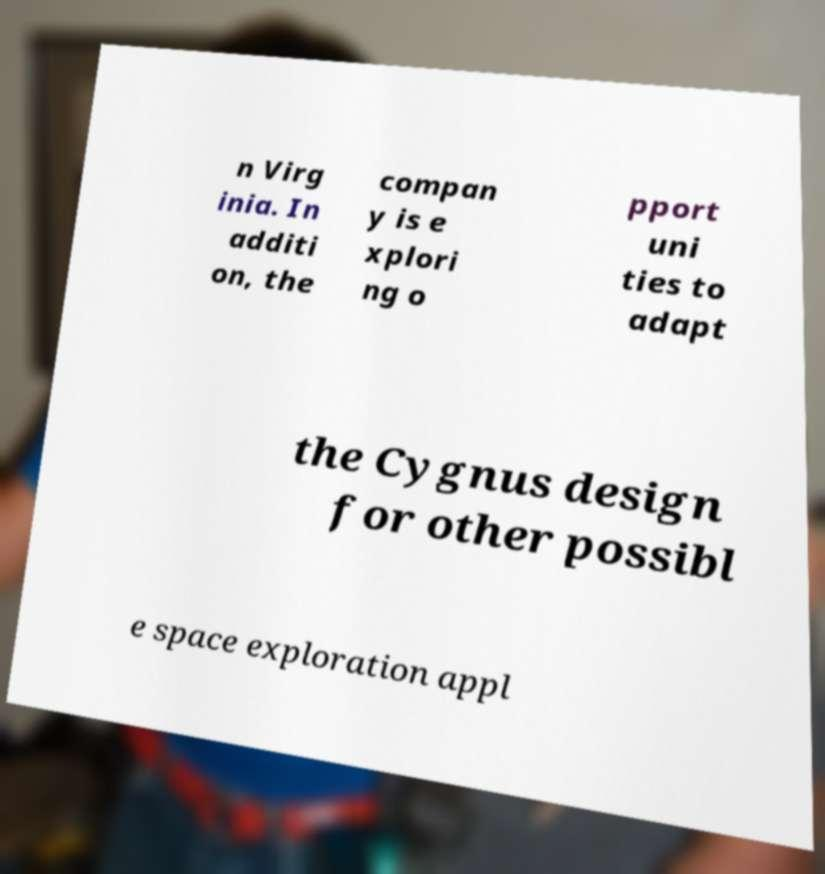Please identify and transcribe the text found in this image. n Virg inia. In additi on, the compan y is e xplori ng o pport uni ties to adapt the Cygnus design for other possibl e space exploration appl 